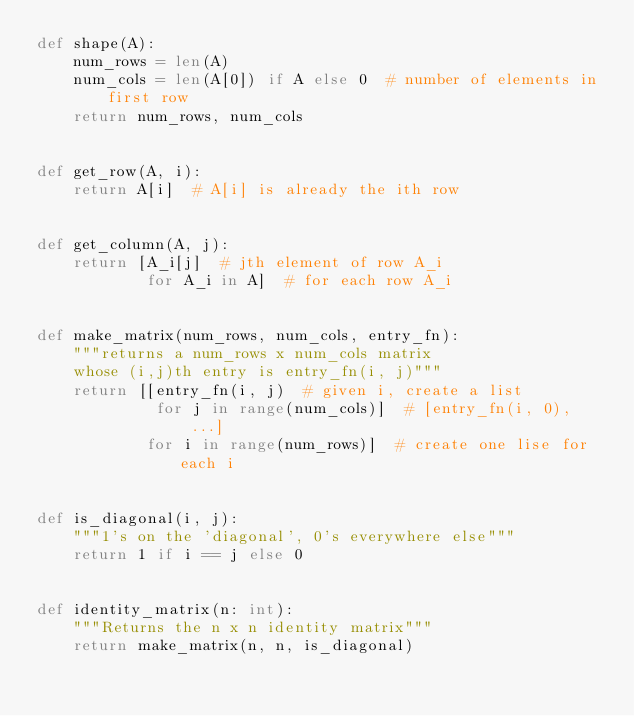Convert code to text. <code><loc_0><loc_0><loc_500><loc_500><_Python_>def shape(A):
    num_rows = len(A)
    num_cols = len(A[0]) if A else 0  # number of elements in first row
    return num_rows, num_cols


def get_row(A, i):
    return A[i]  # A[i] is already the ith row


def get_column(A, j):
    return [A_i[j]  # jth element of row A_i
            for A_i in A]  # for each row A_i


def make_matrix(num_rows, num_cols, entry_fn):
    """returns a num_rows x num_cols matrix
    whose (i,j)th entry is entry_fn(i, j)"""
    return [[entry_fn(i, j)  # given i, create a list
             for j in range(num_cols)]  # [entry_fn(i, 0), ...]
            for i in range(num_rows)]  # create one lise for each i


def is_diagonal(i, j):
    """1's on the 'diagonal', 0's everywhere else"""
    return 1 if i == j else 0


def identity_matrix(n: int):
    """Returns the n x n identity matrix"""
    return make_matrix(n, n, is_diagonal)


</code> 